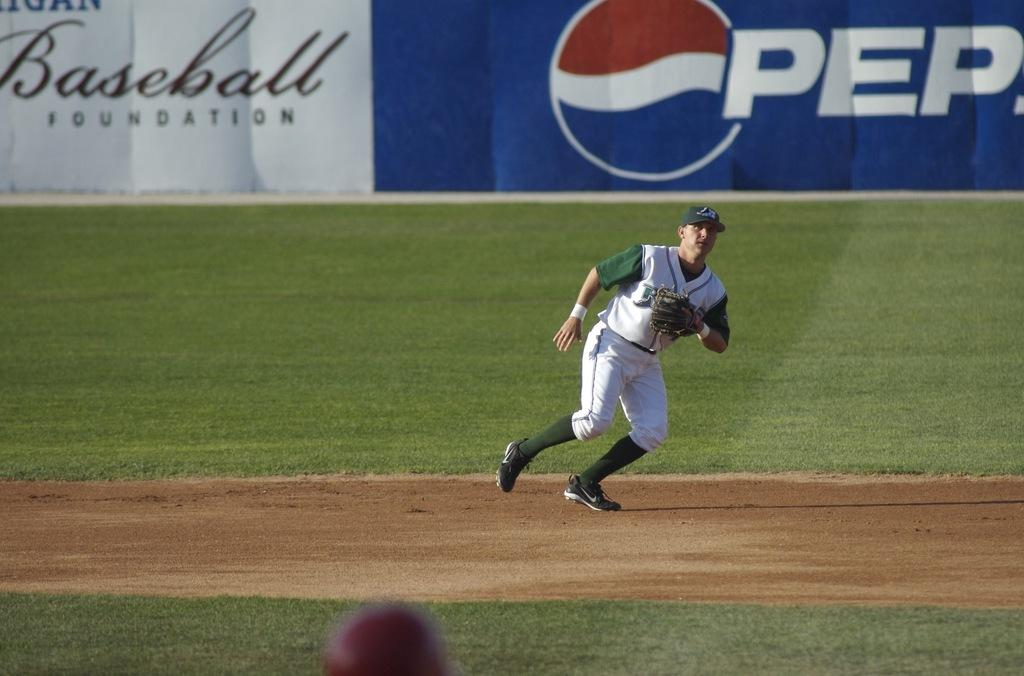<image>
Create a compact narrative representing the image presented. A Baseball Foundation sign can be seen behind a baseball player. 